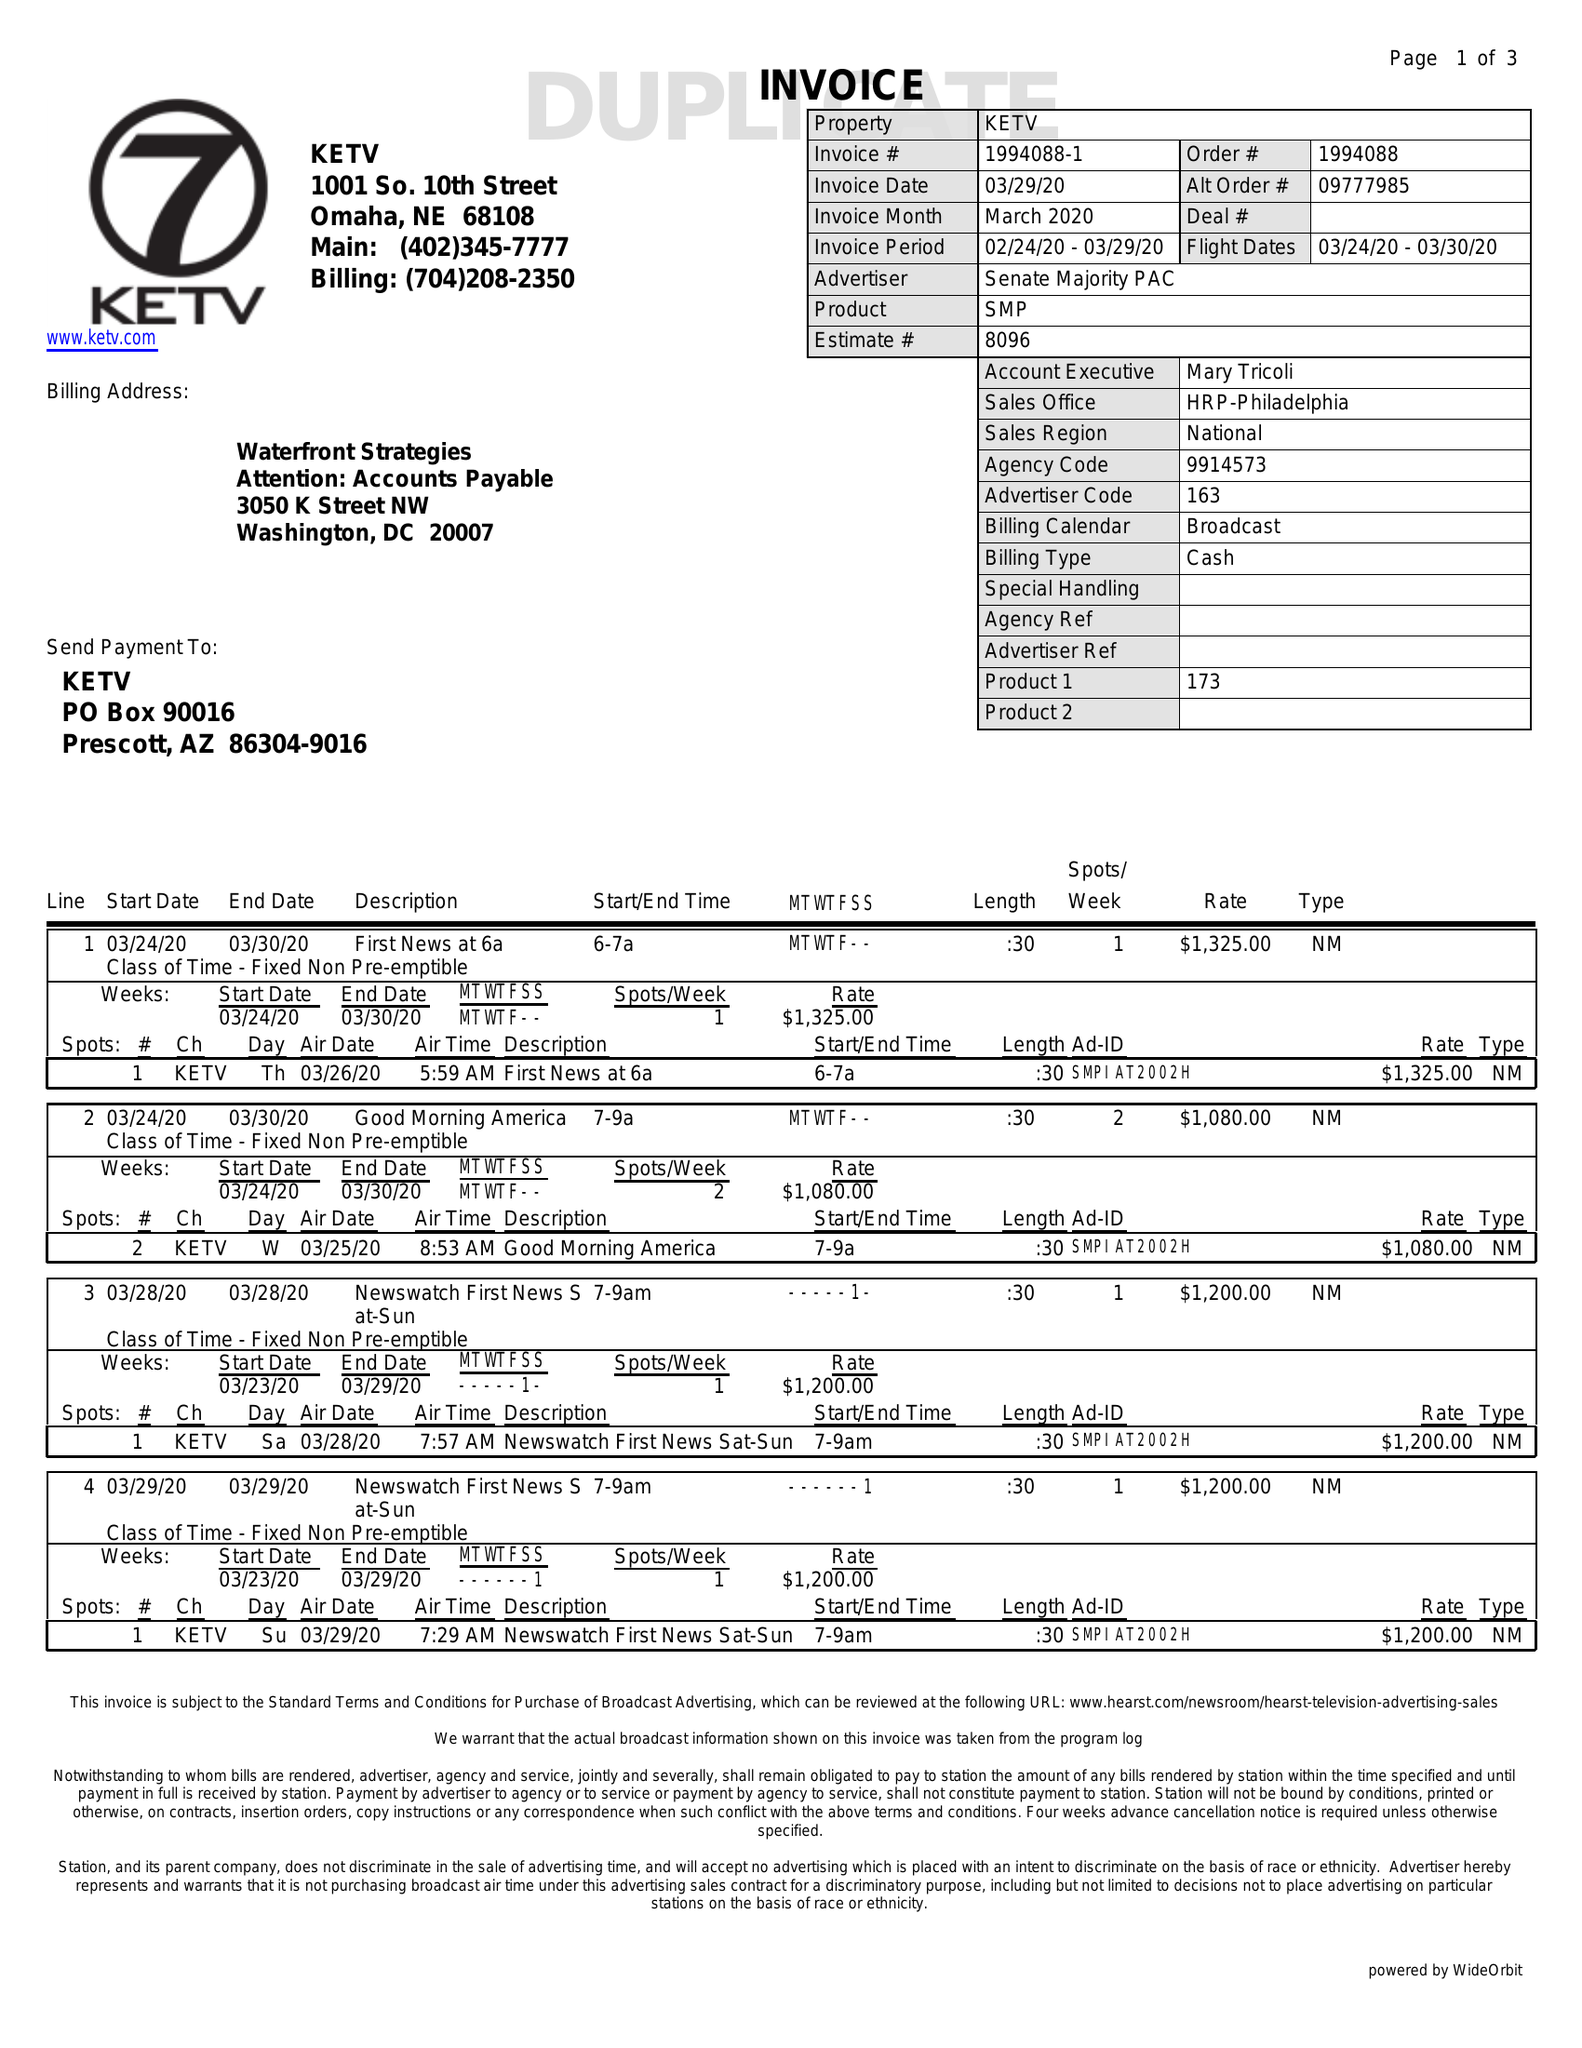What is the value for the flight_to?
Answer the question using a single word or phrase. 03/30/20 